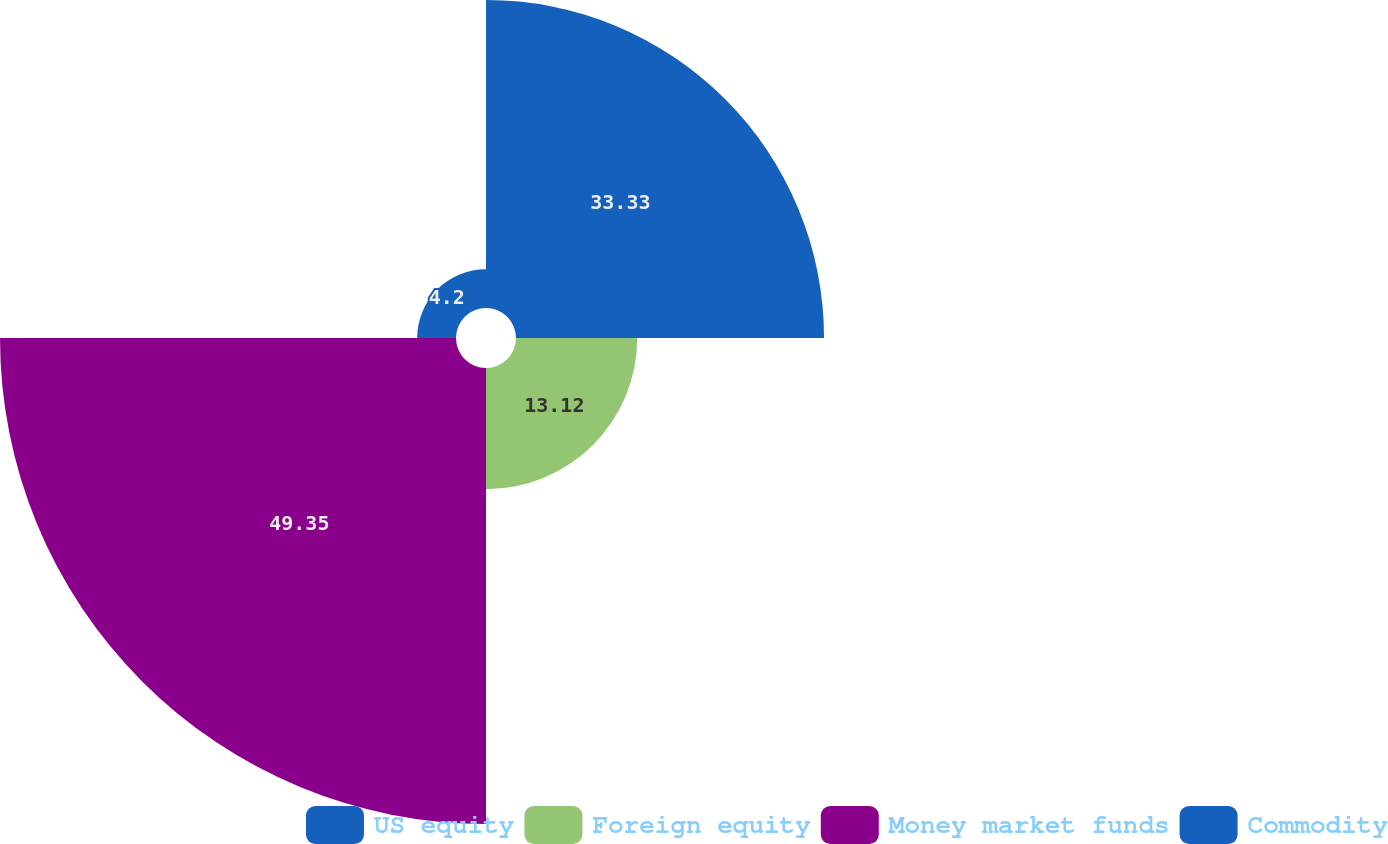Convert chart. <chart><loc_0><loc_0><loc_500><loc_500><pie_chart><fcel>US equity<fcel>Foreign equity<fcel>Money market funds<fcel>Commodity<nl><fcel>33.33%<fcel>13.12%<fcel>49.34%<fcel>4.2%<nl></chart> 